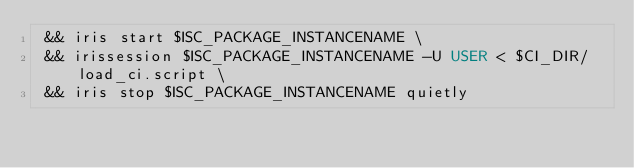Convert code to text. <code><loc_0><loc_0><loc_500><loc_500><_Dockerfile_> && iris start $ISC_PACKAGE_INSTANCENAME \
 && irissession $ISC_PACKAGE_INSTANCENAME -U USER < $CI_DIR/load_ci.script \
 && iris stop $ISC_PACKAGE_INSTANCENAME quietly</code> 